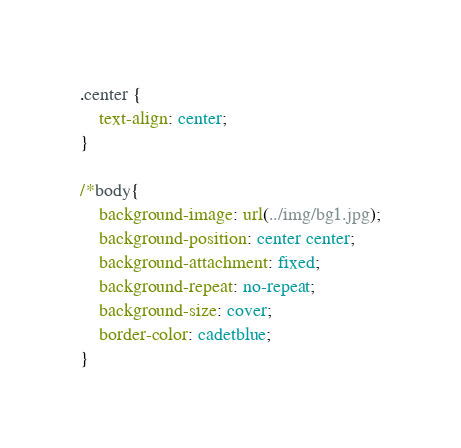<code> <loc_0><loc_0><loc_500><loc_500><_CSS_>.center {
    text-align: center;
}

/*body{
    background-image: url(../img/bg1.jpg);
    background-position: center center;
    background-attachment: fixed;
    background-repeat: no-repeat;
    background-size: cover;
    border-color: cadetblue;
}</code> 